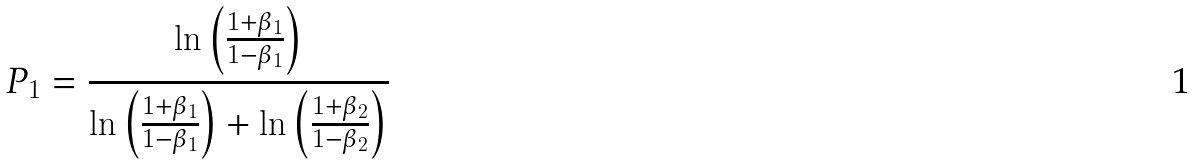<formula> <loc_0><loc_0><loc_500><loc_500>P _ { 1 } = \frac { \ln \left ( \frac { 1 + \beta _ { 1 } } { 1 - \beta _ { 1 } } \right ) } { \ln \left ( \frac { 1 + \beta _ { 1 } } { 1 - \beta _ { 1 } } \right ) + \ln \left ( \frac { 1 + \beta _ { 2 } } { 1 - \beta _ { 2 } } \right ) }</formula> 